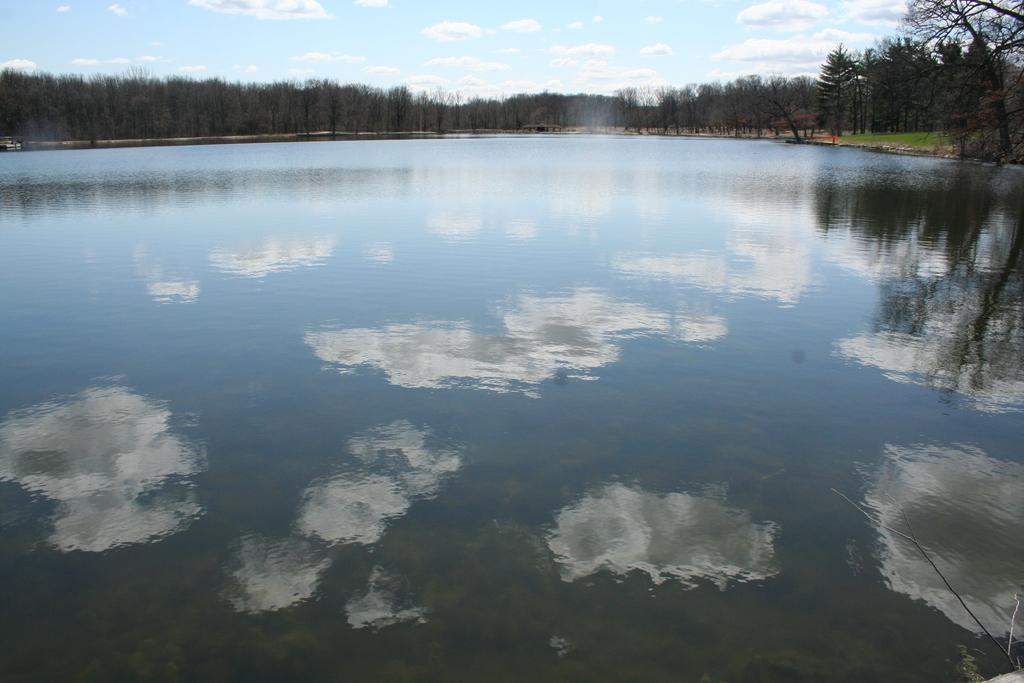What is the primary element visible in the image? There is water in the image. Can you describe the possible location of the water? The water might be in a lake. What type of vegetation can be seen in the background of the image? There are trees in the background of the image. What is visible at the top of the image? The sky is visible at the top of the image. What can be observed in the sky? Clouds are present in the sky. What type of sack can be seen floating on the water in the image? There is no sack present in the image; it only features water, trees, and clouds. 